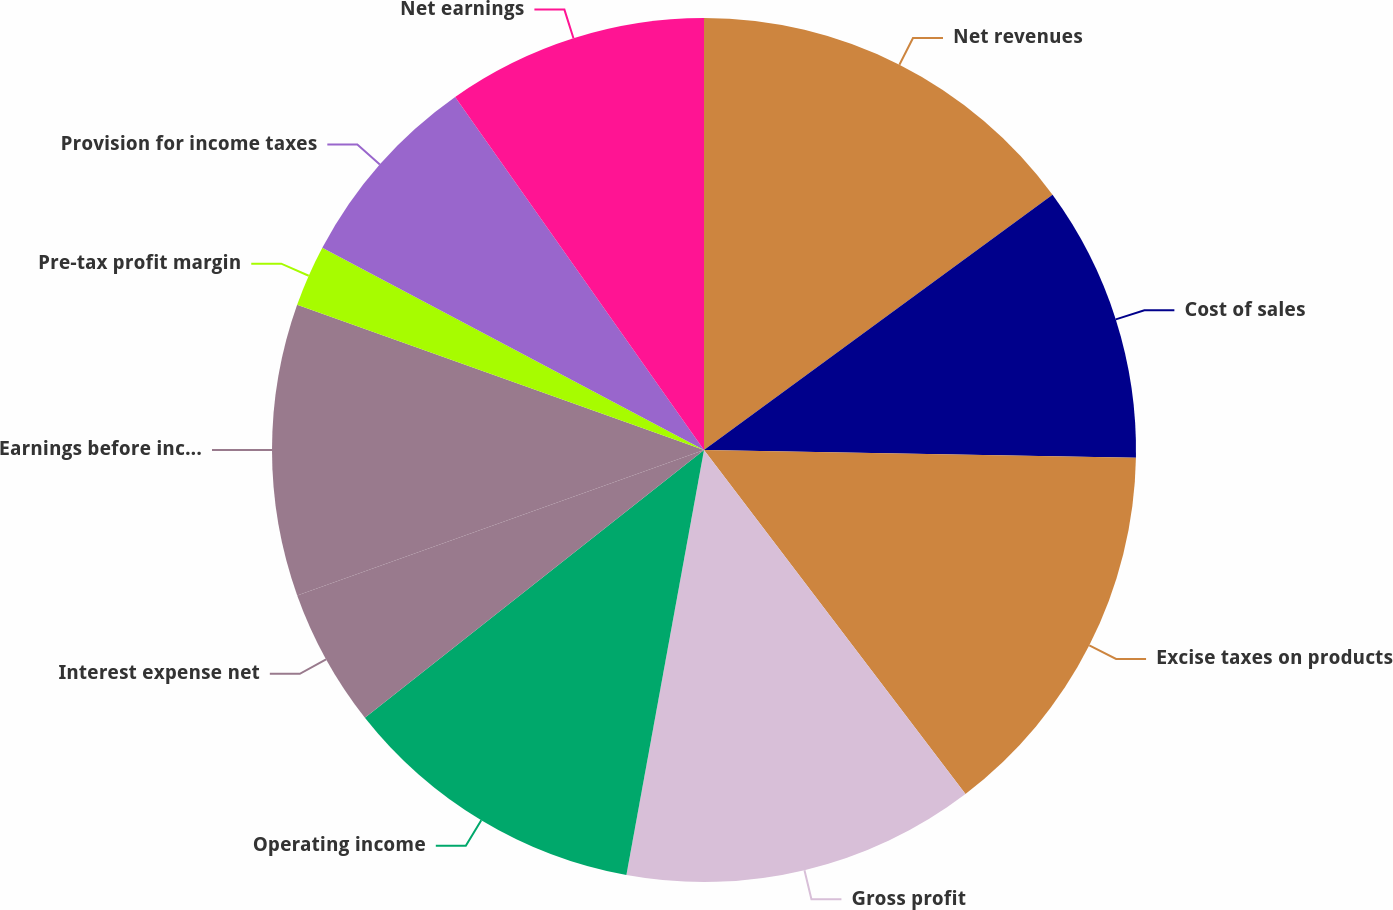Convert chart. <chart><loc_0><loc_0><loc_500><loc_500><pie_chart><fcel>Net revenues<fcel>Cost of sales<fcel>Excise taxes on products<fcel>Gross profit<fcel>Operating income<fcel>Interest expense net<fcel>Earnings before income taxes<fcel>Pre-tax profit margin<fcel>Provision for income taxes<fcel>Net earnings<nl><fcel>14.94%<fcel>10.34%<fcel>14.37%<fcel>13.22%<fcel>11.49%<fcel>5.17%<fcel>10.92%<fcel>2.3%<fcel>7.47%<fcel>9.77%<nl></chart> 